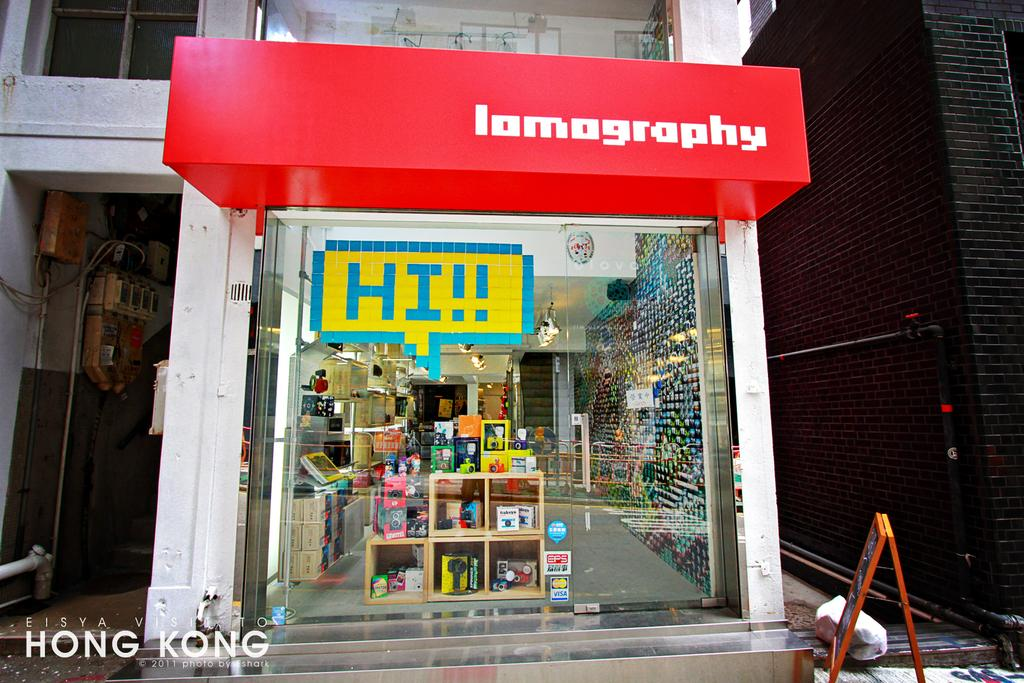<image>
Summarize the visual content of the image. The hello chat bubble reads Hi!! inside of it 